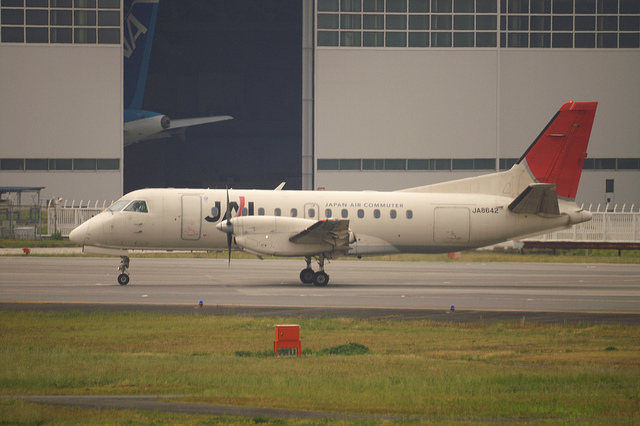Identify the text contained in this image. JA6042 